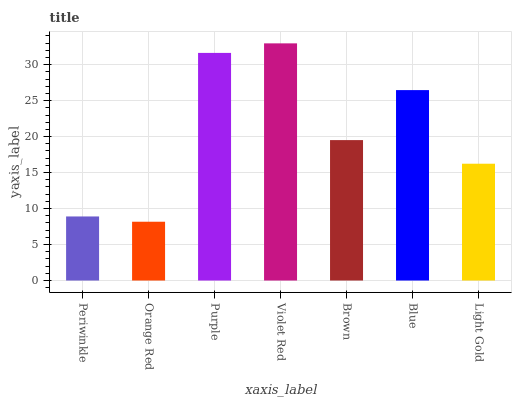Is Orange Red the minimum?
Answer yes or no. Yes. Is Violet Red the maximum?
Answer yes or no. Yes. Is Purple the minimum?
Answer yes or no. No. Is Purple the maximum?
Answer yes or no. No. Is Purple greater than Orange Red?
Answer yes or no. Yes. Is Orange Red less than Purple?
Answer yes or no. Yes. Is Orange Red greater than Purple?
Answer yes or no. No. Is Purple less than Orange Red?
Answer yes or no. No. Is Brown the high median?
Answer yes or no. Yes. Is Brown the low median?
Answer yes or no. Yes. Is Blue the high median?
Answer yes or no. No. Is Light Gold the low median?
Answer yes or no. No. 